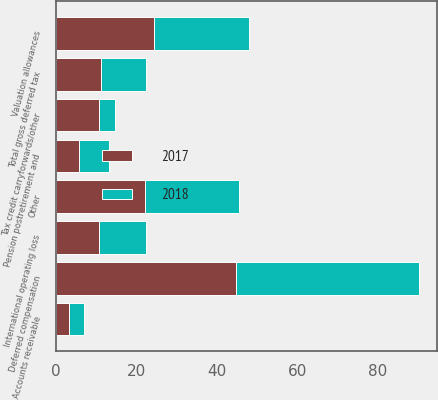Convert chart. <chart><loc_0><loc_0><loc_500><loc_500><stacked_bar_chart><ecel><fcel>Accounts receivable<fcel>Deferred compensation<fcel>Pension postretirement and<fcel>Other<fcel>Tax credit carryforwards/other<fcel>International operating loss<fcel>Total gross deferred tax<fcel>Valuation allowances<nl><fcel>2017<fcel>3.4<fcel>44.8<fcel>5.8<fcel>22.1<fcel>10.7<fcel>10.8<fcel>11.2<fcel>24.5<nl><fcel>2018<fcel>3.7<fcel>45.5<fcel>7.5<fcel>23.4<fcel>3.9<fcel>11.6<fcel>11.2<fcel>23.5<nl></chart> 